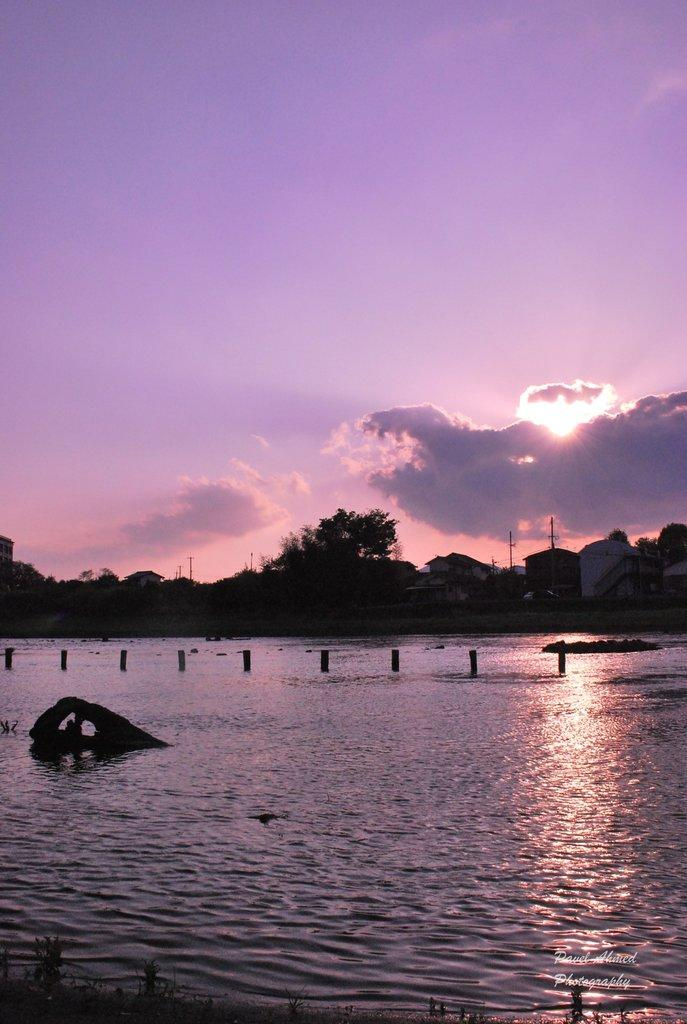What can be seen in the sky in the image? The sky is visible in the image. What type of natural vegetation is present in the image? There are many trees in the image. What type of structures can be seen in the image? There are many houses in the image. What body of water is present in the image? There is a lake in the image. What is the condition of the water in the image? There are few objects in the water in the image. What type of zephyr can be seen blowing through the trees in the image? There is no zephyr present in the image; it is a still scene with no visible wind. What type of base is supporting the houses in the image? The houses in the image are built on solid ground, and there is no specific base mentioned or visible in the image. 